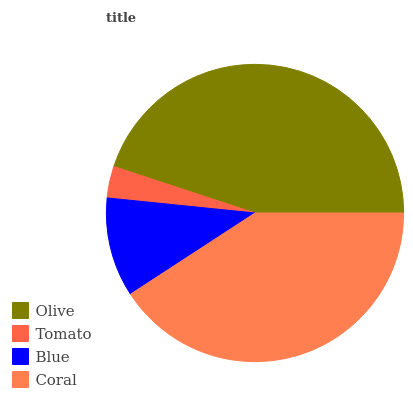Is Tomato the minimum?
Answer yes or no. Yes. Is Olive the maximum?
Answer yes or no. Yes. Is Blue the minimum?
Answer yes or no. No. Is Blue the maximum?
Answer yes or no. No. Is Blue greater than Tomato?
Answer yes or no. Yes. Is Tomato less than Blue?
Answer yes or no. Yes. Is Tomato greater than Blue?
Answer yes or no. No. Is Blue less than Tomato?
Answer yes or no. No. Is Coral the high median?
Answer yes or no. Yes. Is Blue the low median?
Answer yes or no. Yes. Is Olive the high median?
Answer yes or no. No. Is Coral the low median?
Answer yes or no. No. 